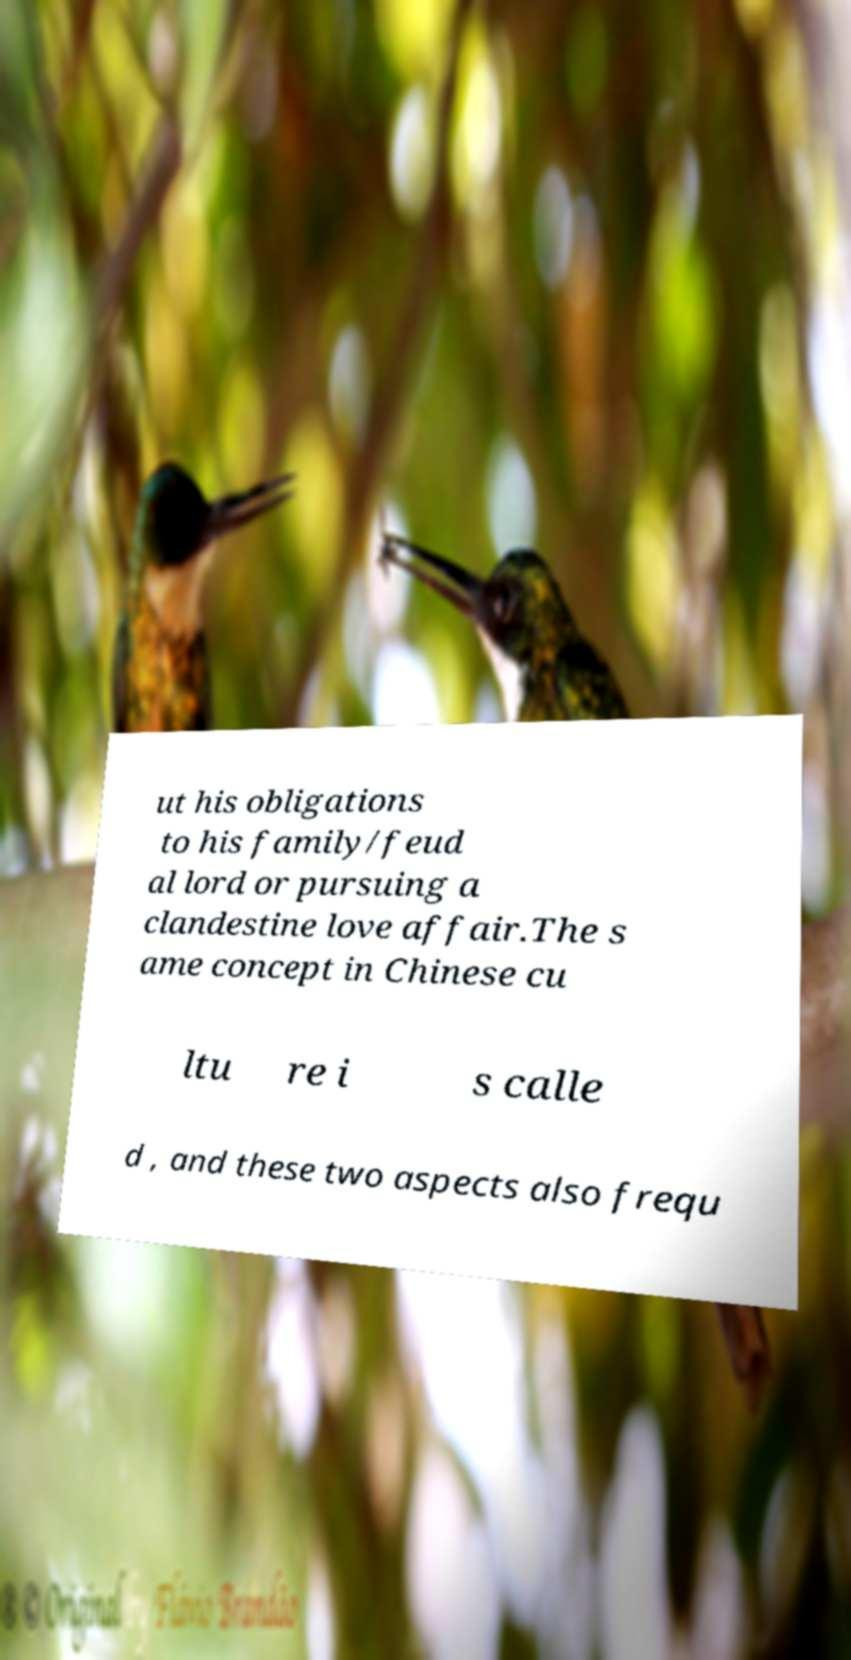Can you read and provide the text displayed in the image?This photo seems to have some interesting text. Can you extract and type it out for me? ut his obligations to his family/feud al lord or pursuing a clandestine love affair.The s ame concept in Chinese cu ltu re i s calle d , and these two aspects also frequ 